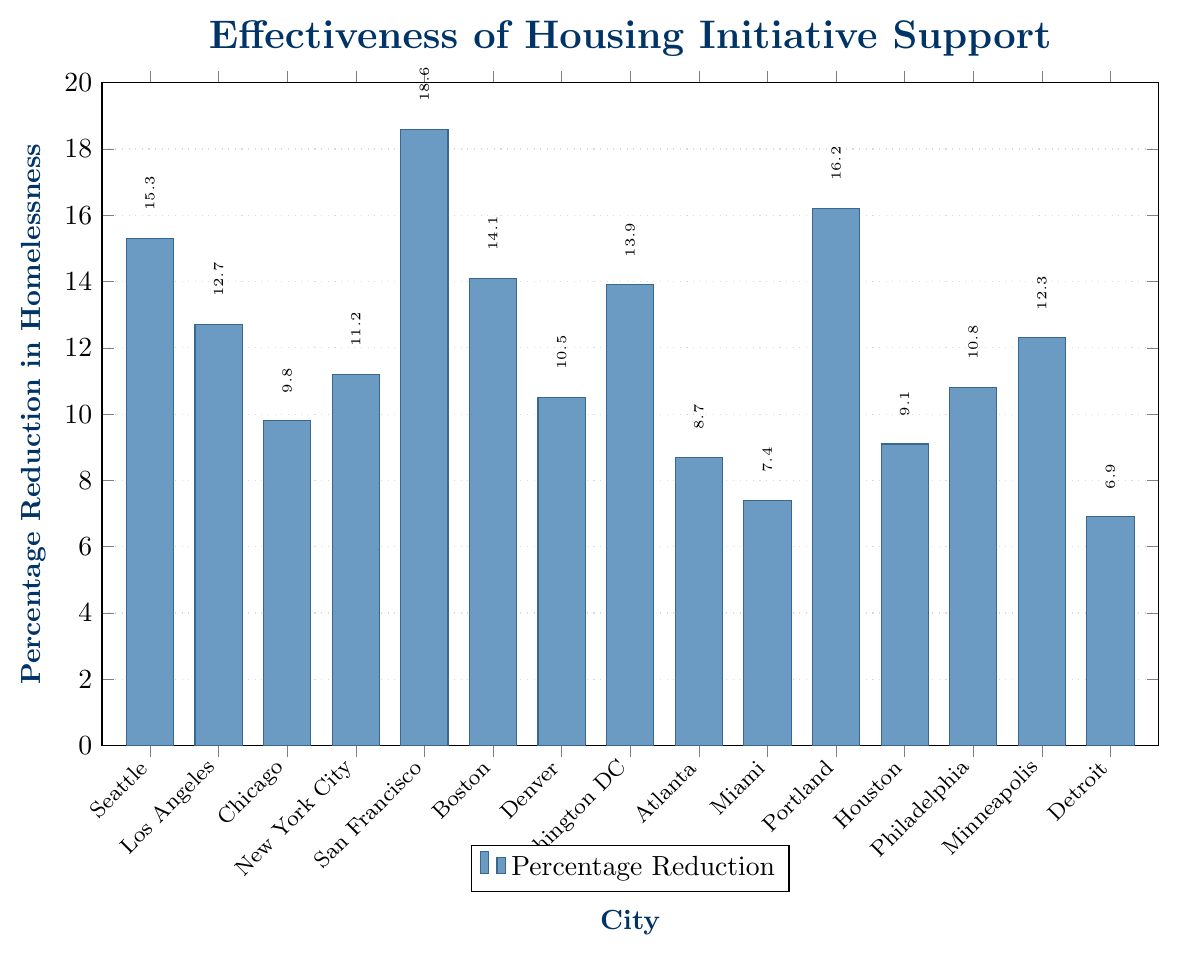What city has the highest percentage reduction in homelessness? By looking at the bar heights, San Francisco has the tallest bar, indicating the highest percentage reduction.
Answer: San Francisco Which cities have a percentage reduction above 15%? The cities with bars extending above the 15% mark are Seattle, San Francisco, and Portland.
Answer: Seattle, San Francisco, Portland What is the difference in percentage reduction between the city with the highest reduction and the city with the lowest reduction? The highest reduction is in San Francisco (18.6%) and the lowest is in Detroit (6.9%). The difference is 18.6% - 6.9% = 11.7%.
Answer: 11.7% Which city has a percentage reduction closest to 10%? Among the cities, Denver (10.5%) and Philadelphia (10.8%) are close, but Denver's value of 10.5% is the nearest to 10%.
Answer: Denver Is the percentage reduction in homelessness for Boston greater than that for Washington DC? The bar for Boston (14.1%) is slightly taller than that for Washington DC (13.9%), so the percentage reduction for Boston is indeed greater.
Answer: Yes What is the average percentage reduction across all the cities? Sum all percentages: 15.3 + 12.7 + 9.8 + 11.2 + 18.6 + 14.1 + 10.5 + 13.9 + 8.7 + 7.4 + 16.2 + 9.1 + 10.8 + 12.3 + 6.9 = 177.5. There are 15 cities, so the average is 177.5 / 15 = 11.83%.
Answer: 11.83% Which city has a lower percentage reduction, Los Angeles or Chicago? By comparing the heights of the bars, Chicago has a reduction of 9.8%, which is lower than Los Angeles's 12.7%.
Answer: Chicago How many cities have a percentage reduction of less than 10%? The cities with a reduction of less than 10% are Chicago (9.8%), Atlanta (8.7%), Miami (7.4%), Houston (9.1%), and Detroit (6.9%). There are 5 such cities.
Answer: 5 Is New York City's percentage reduction in homelessness more than the average percentage reduction across all cities? First, calculate the average percentage reduction (11.83%). New York City has an 11.2% reduction. Since 11.2% is less than 11.83%, New York City's reduction is less than the average.
Answer: No 